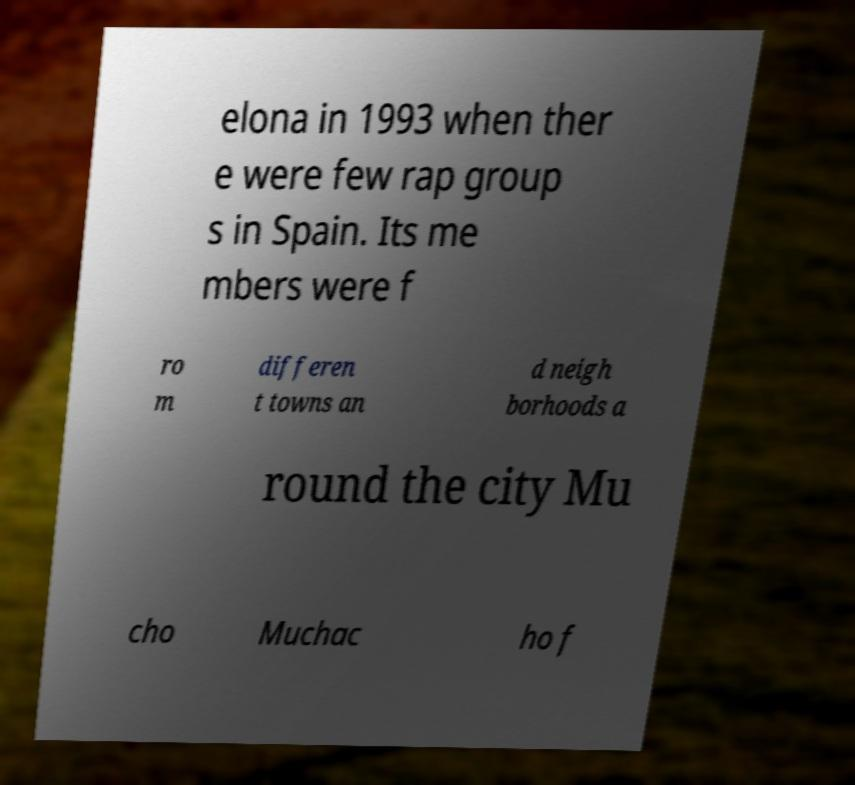Please read and relay the text visible in this image. What does it say? elona in 1993 when ther e were few rap group s in Spain. Its me mbers were f ro m differen t towns an d neigh borhoods a round the city Mu cho Muchac ho f 